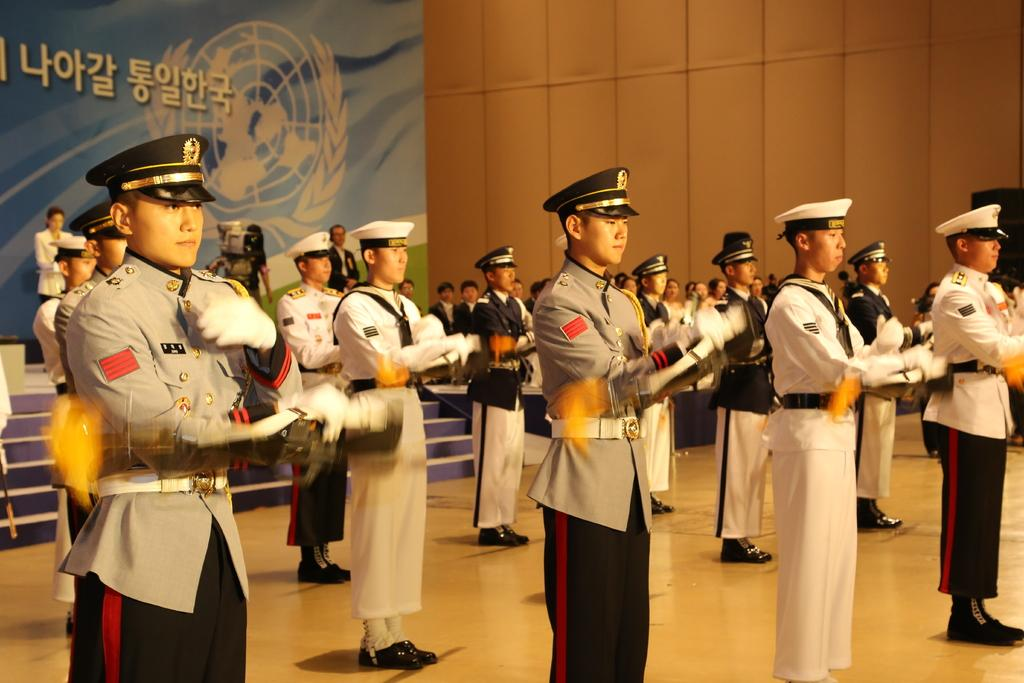What are the people in the image doing? The people in the image are standing. What are the people wearing on their heads? The people are wearing caps. What are the people wearing on their hands? The people are wearing gloves. What can be seen in the background of the image? There are stairs and additional people visible in the background. What type of button can be seen on the square in the image? There is no button or square present in the image. 